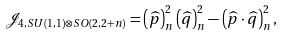<formula> <loc_0><loc_0><loc_500><loc_500>\mathcal { J } _ { 4 , S U ( 1 , 1 ) \otimes S O ( 2 , 2 + n ) } = \left ( \widehat { p } \right ) _ { n } ^ { 2 } \left ( \widehat { q } \right ) _ { n } ^ { 2 } - \left ( \widehat { p } \cdot \widehat { q } \right ) _ { n } ^ { 2 } ,</formula> 